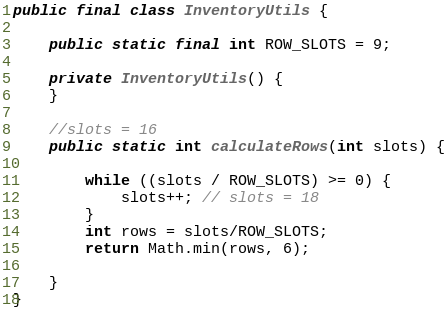Convert code to text. <code><loc_0><loc_0><loc_500><loc_500><_Java_>public final class InventoryUtils {

    public static final int ROW_SLOTS = 9;

    private InventoryUtils() {
    }

    //slots = 16
    public static int calculateRows(int slots) {

        while ((slots / ROW_SLOTS) >= 0) {
            slots++; // slots = 18
        }
        int rows = slots/ROW_SLOTS;
        return Math.min(rows, 6);

    }
}
</code> 